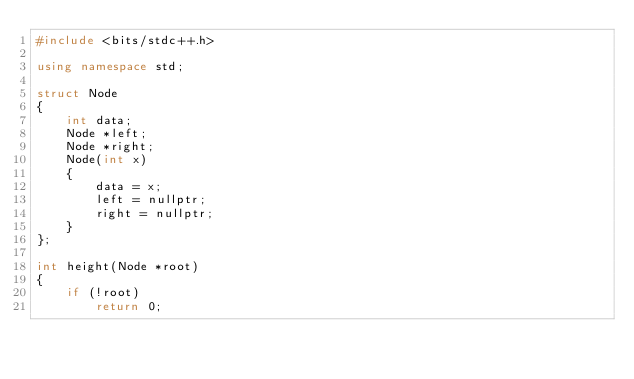Convert code to text. <code><loc_0><loc_0><loc_500><loc_500><_C++_>#include <bits/stdc++.h>

using namespace std;

struct Node
{
    int data;
    Node *left;
    Node *right;
    Node(int x)
    {
        data = x;
        left = nullptr;
        right = nullptr;
    }
};

int height(Node *root)
{
    if (!root)
        return 0;</code> 